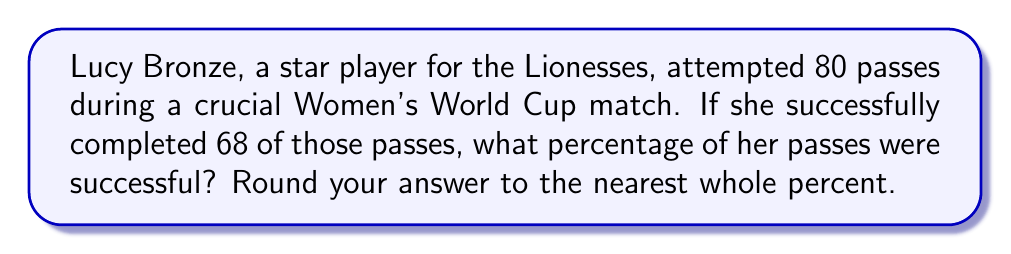Give your solution to this math problem. Let's approach this step-by-step:

1) First, we need to set up the equation for calculating a percentage:

   Percentage = $\frac{\text{Part}}{\text{Whole}} \times 100$

2) In this case:
   - The "Part" is the number of successful passes: 68
   - The "Whole" is the total number of attempted passes: 80

3) Let's plug these numbers into our equation:

   Percentage = $\frac{68}{80} \times 100$

4) Now, let's solve this:
   
   $\frac{68}{80} = 0.85$

   $0.85 \times 100 = 85$

5) The question asks to round to the nearest whole percent, but 85 is already a whole number, so no rounding is necessary.

Therefore, Lucy Bronze's pass success rate was 85%.
Answer: 85% 